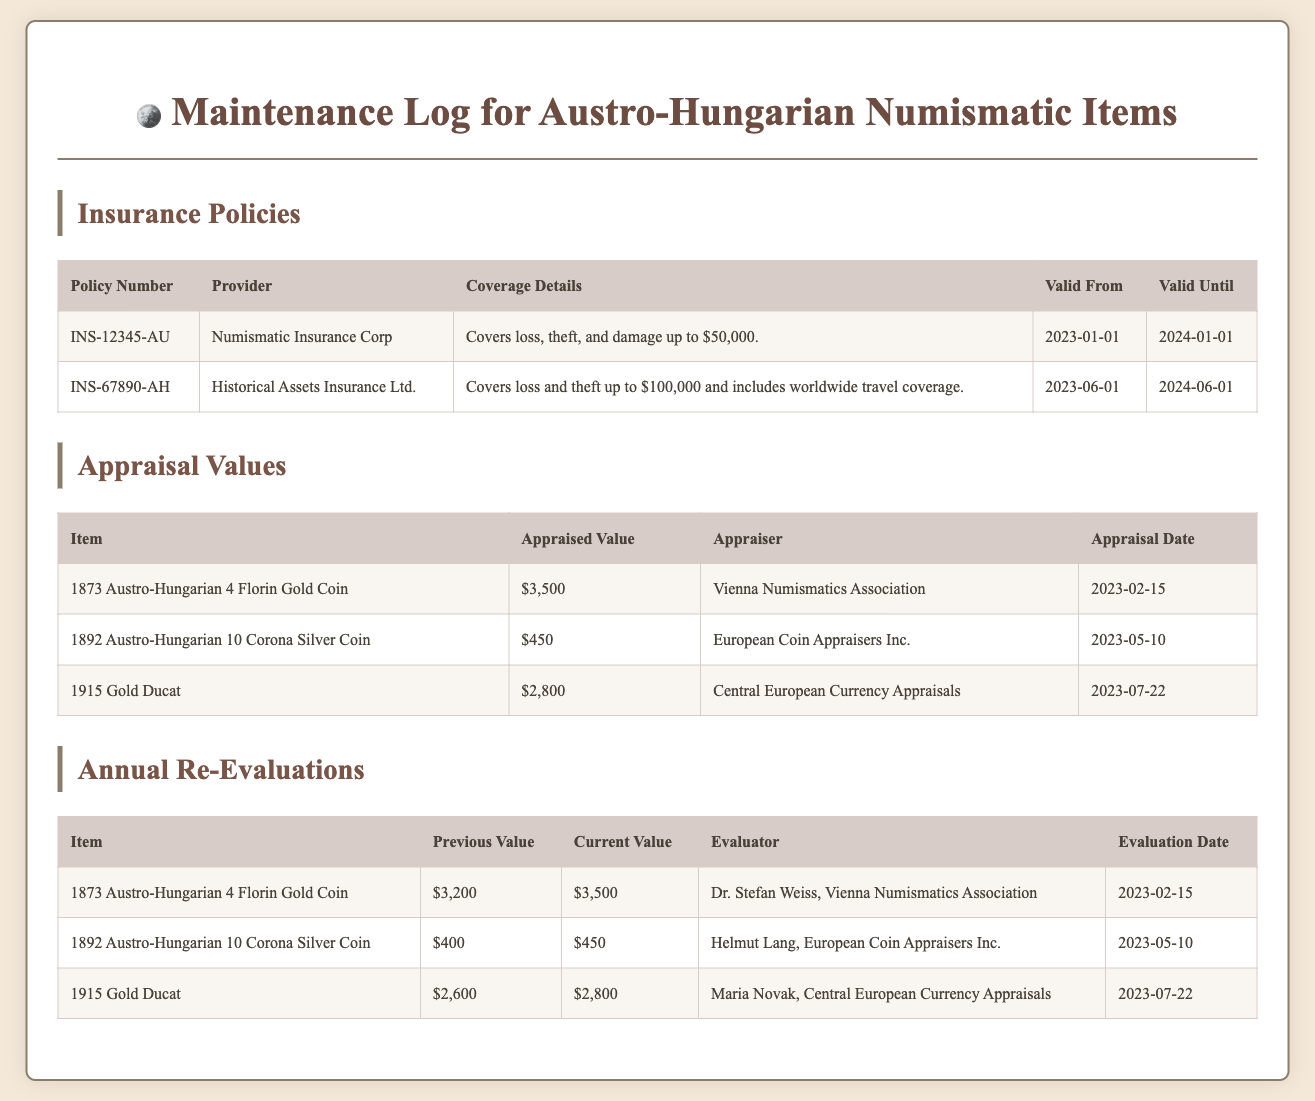What is the policy number for the first insurance? The policy number is listed in the insurance section of the document, specifically for the first entry.
Answer: INS-12345-AU Who is the provider for the insurance policy covering up to $100,000? This information is found in the insurance table under the provider column for the relevant policy.
Answer: Historical Assets Insurance Ltd What is the appraised value of the 1892 Austro-Hungarian 10 Corona Silver Coin? The appraised value is found in the appraisal values table, specifically corresponding to that item.
Answer: $450 Who conducted the appraisal for the 1915 Gold Ducat? The appraiser's name is listed next to the relevant item in the appraisal values section.
Answer: Central European Currency Appraisals What was the previous value of the 1873 Austro-Hungarian 4 Florin Gold Coin? This information is found in the annual re-evaluations table under the previous value column for that item.
Answer: $3,200 What is the coverage limit of the insurance policy from Numismatic Insurance Corp? This detail is specified in the insurance coverage details column for that policy.
Answer: $50,000 When is the valid date until for the second insurance policy? The valid date is recorded in the insurance section under the valid until column for that policy.
Answer: 2024-06-01 What was the evaluation date for the annual re-evaluation of the 1892 Austro-Hungarian 10 Corona Silver Coin? This date is located under the evaluation date column for that item in the annual re-evaluations table.
Answer: 2023-05-10 What type of items are recorded in this maintenance log? The document specifically records information related to numismatic items from a historical empire.
Answer: Austro-Hungarian numismatic items 